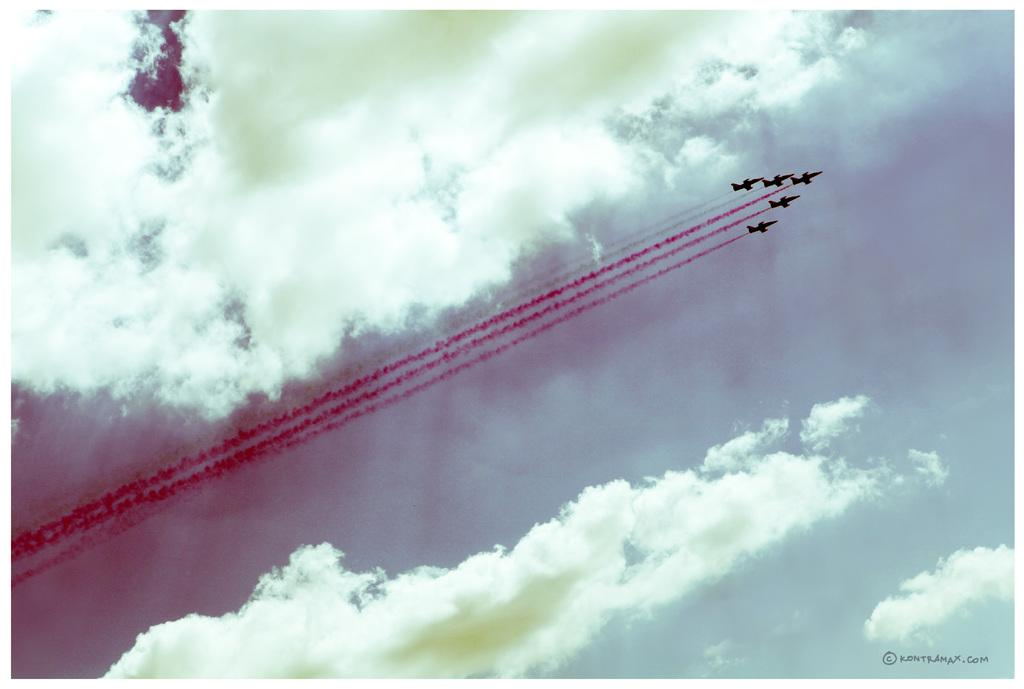How many jet planes can be seen in the image? There are five jet planes in the air in the image. What can be seen coming from the jet planes? Smoke is visible in the image. What is visible in the background of the image? The sky and clouds are present in the background of the image. Where is the text located in the image? The text is at the right bottom of the image. What type of sweater is the jet plane wearing in the image? Jet planes do not wear sweaters; they are aircraft and do not have clothing. 